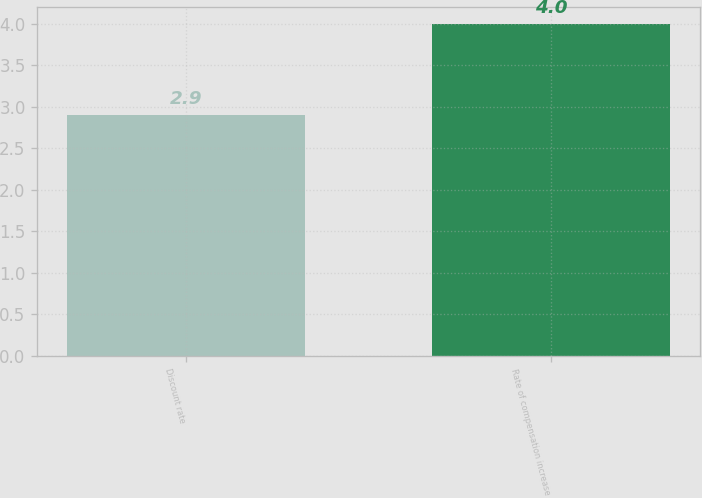Convert chart to OTSL. <chart><loc_0><loc_0><loc_500><loc_500><bar_chart><fcel>Discount rate<fcel>Rate of compensation increase<nl><fcel>2.9<fcel>4<nl></chart> 